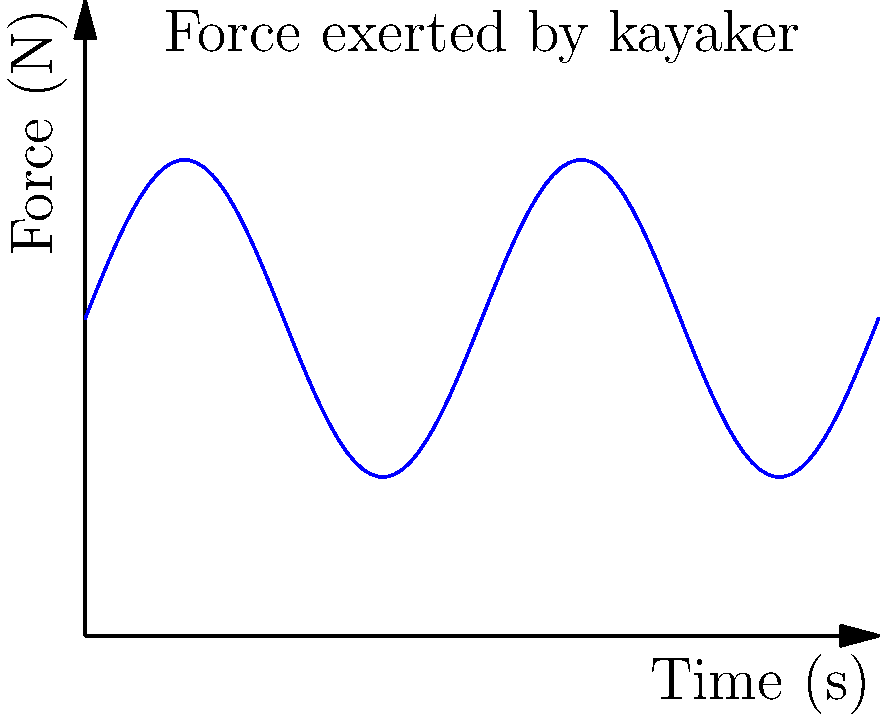The graph shows the force exerted by a kayaker's upper body while paddling on the Thunder Bay River over a 10-second interval. What is the average force exerted during this period? To find the average force exerted by the kayaker over the 10-second interval, we need to follow these steps:

1. Identify the function representing the force:
   The force $F(t)$ is given by $F(t) = 4 + 2\sin(2\pi t/5)$ Newtons, where $t$ is time in seconds.

2. Calculate the average force using the formula:
   $\text{Average Force} = \frac{1}{b-a}\int_{a}^{b} F(t) dt$
   where $a=0$ and $b=10$ are the start and end times of the interval.

3. Solve the integral:
   $\text{Average Force} = \frac{1}{10-0}\int_{0}^{10} (4 + 2\sin(2\pi t/5)) dt$
   $= \frac{1}{10}[4t - \frac{5}{\pi}\cos(2\pi t/5)]_{0}^{10}$

4. Evaluate the integral:
   $= \frac{1}{10}[(40 - \frac{5}{\pi}\cos(4\pi)) - (0 - \frac{5}{\pi}\cos(0))]$
   $= \frac{1}{10}[40 - \frac{5}{\pi}\cos(4\pi) + \frac{5}{\pi}]$

5. Simplify:
   $= 4 - \frac{1}{2\pi}\cos(4\pi) + \frac{1}{2\pi}$
   $= 4 + \frac{1}{2\pi}(1 - \cos(4\pi))$
   $= 4$ (since $\cos(4\pi) = 1$)

Therefore, the average force exerted by the kayaker over the 10-second interval is 4 Newtons.
Answer: 4 N 